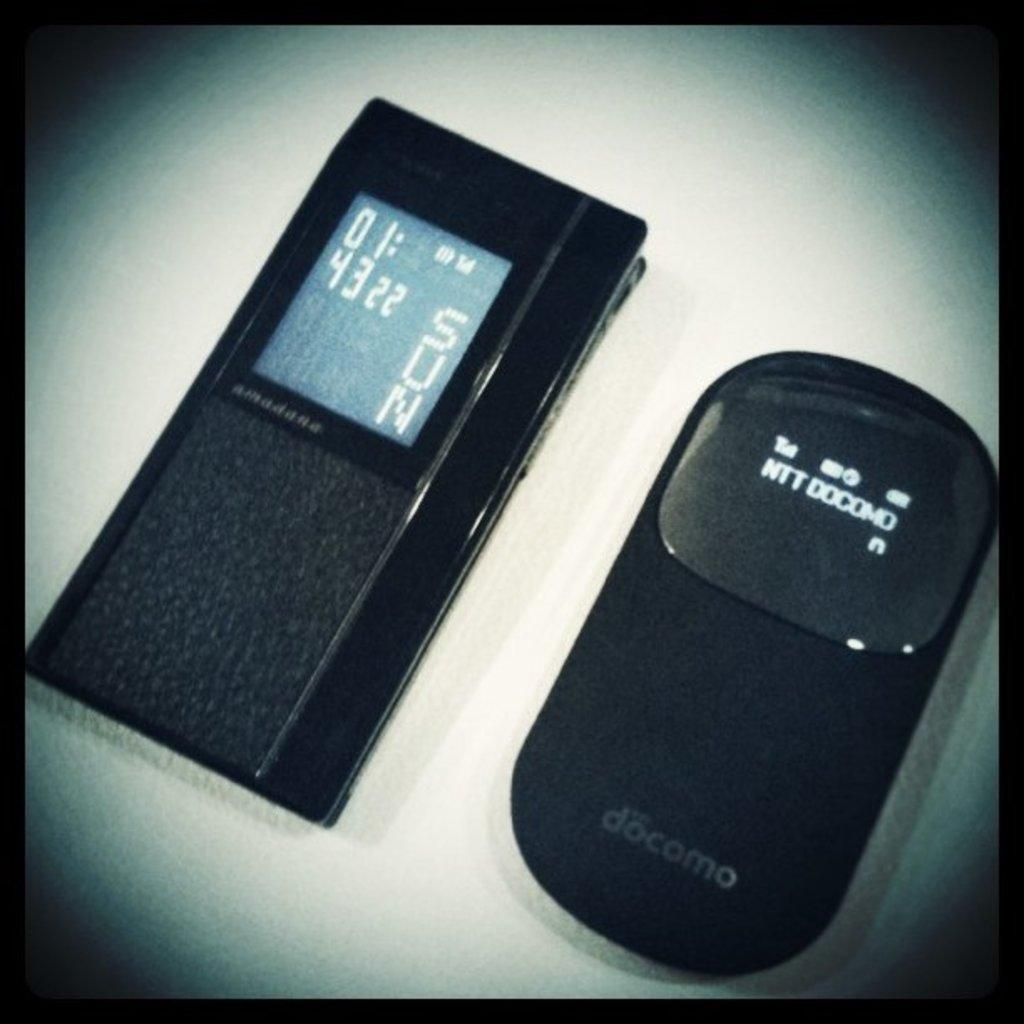<image>
Summarize the visual content of the image. Two electronic devices are next to each other including one made by Docomo. 